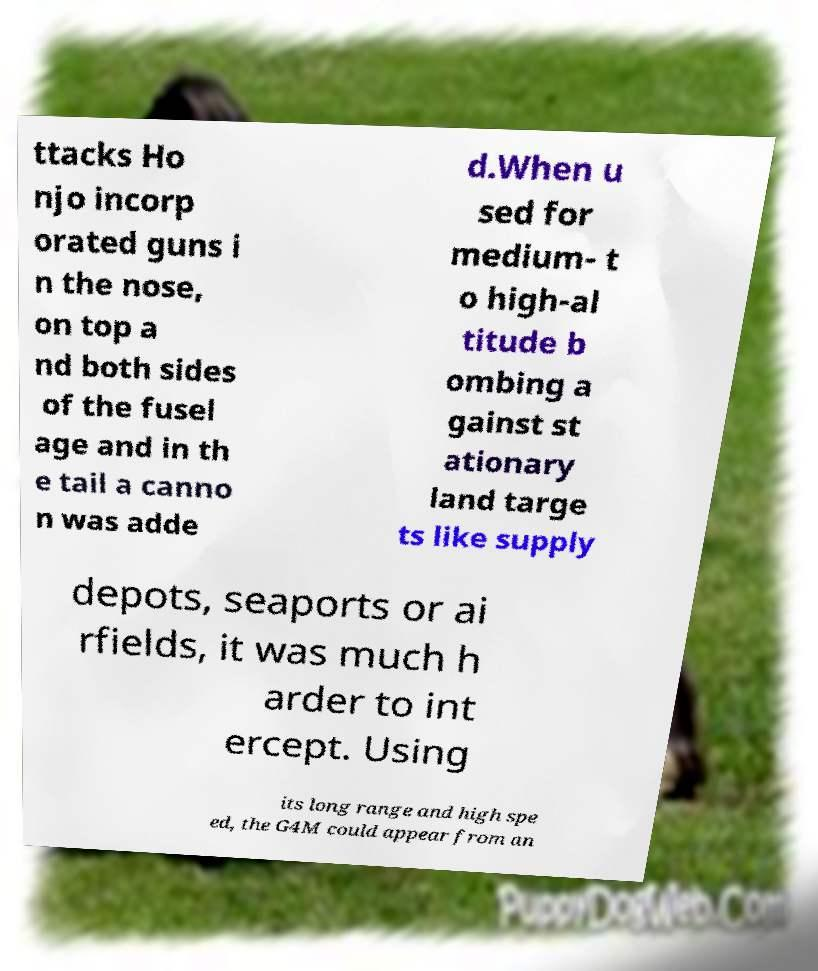What messages or text are displayed in this image? I need them in a readable, typed format. ttacks Ho njo incorp orated guns i n the nose, on top a nd both sides of the fusel age and in th e tail a canno n was adde d.When u sed for medium- t o high-al titude b ombing a gainst st ationary land targe ts like supply depots, seaports or ai rfields, it was much h arder to int ercept. Using its long range and high spe ed, the G4M could appear from an 